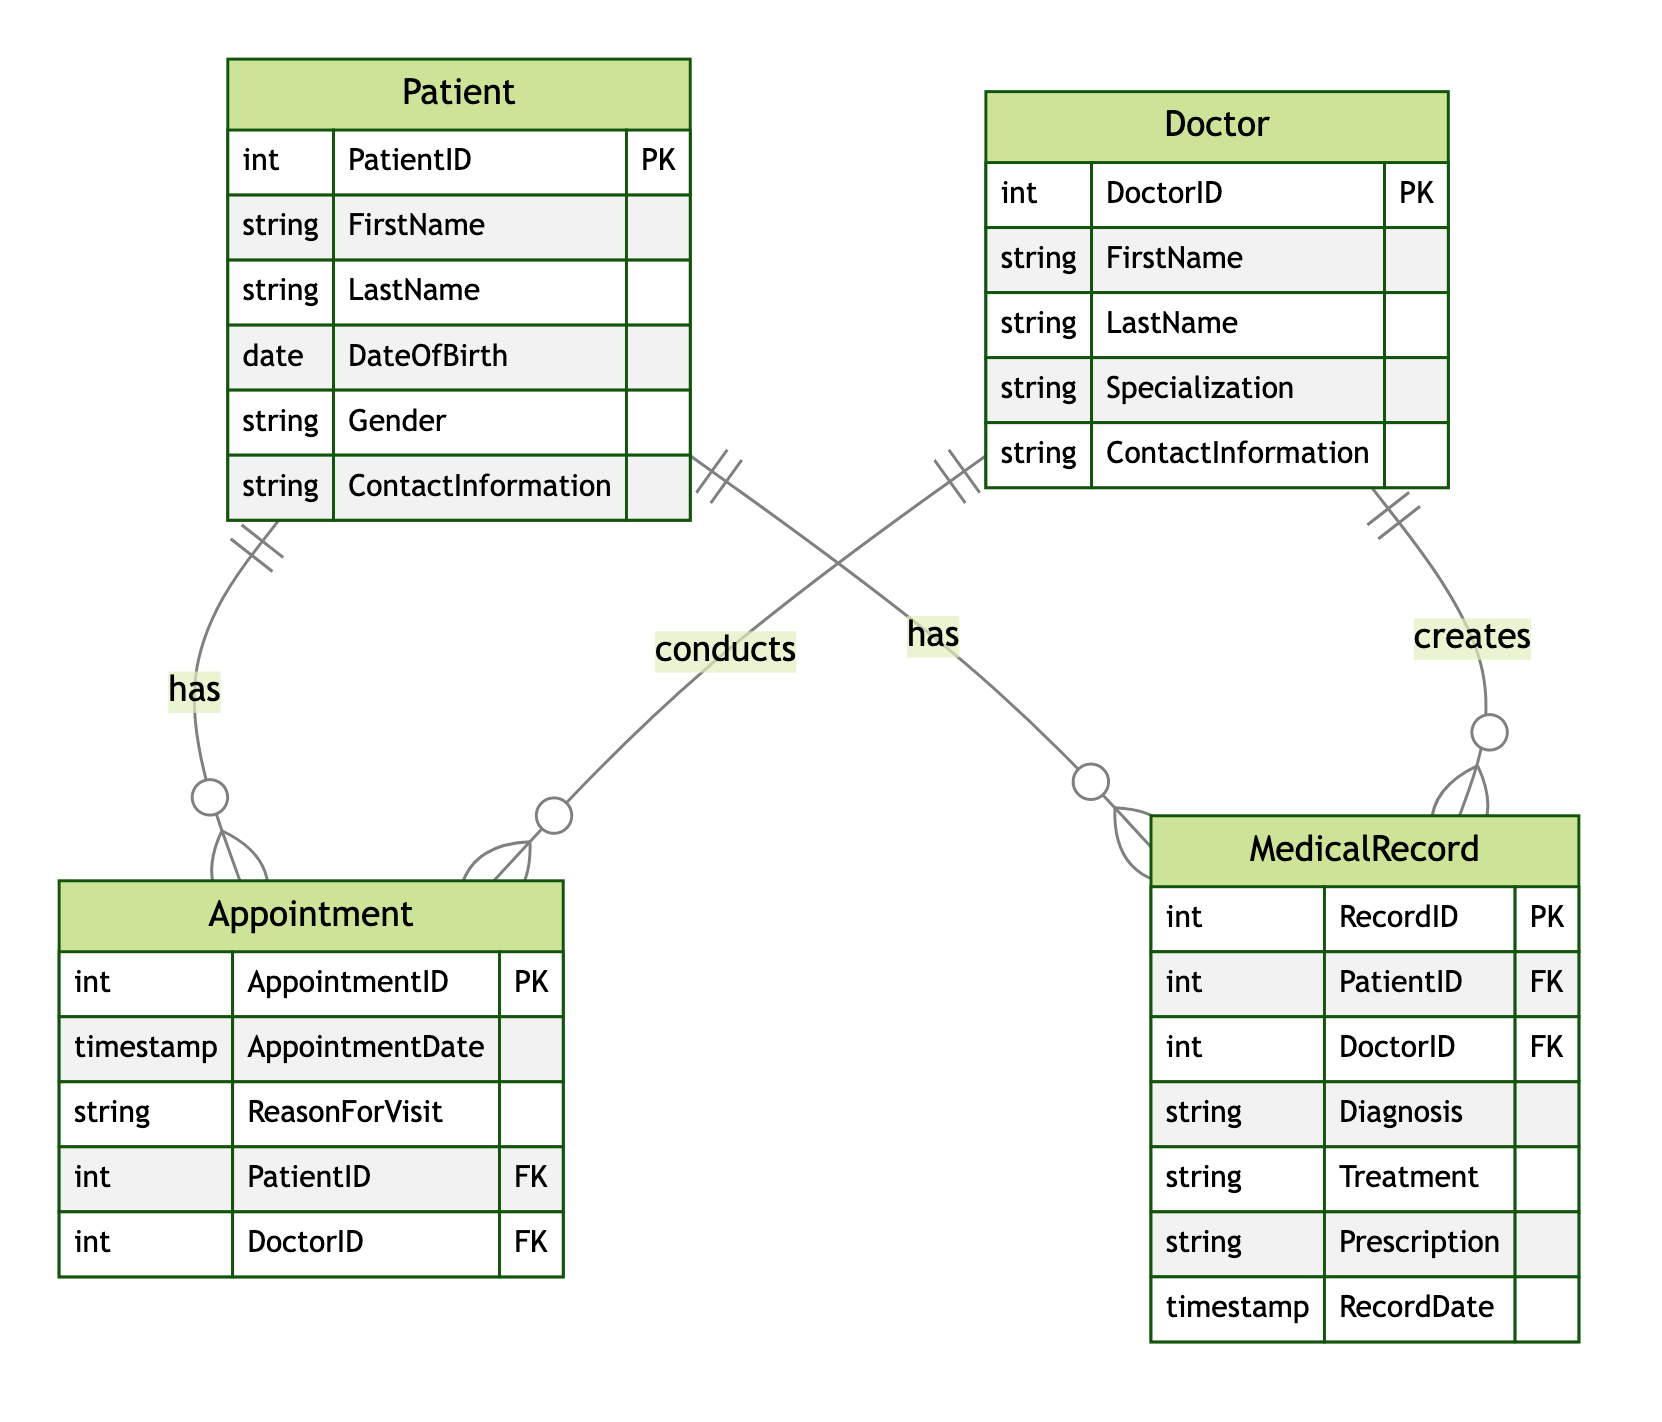What is the primary key for the Patient entity? The primary key is specified in the diagram as "PatientID," which uniquely identifies each patient in the database.
Answer: PatientID How many attributes are there in the Doctor entity? By counting the attributes listed under the Doctor entity, we find that there are five: DoctorID, FirstName, LastName, Specialization, and ContactInformation.
Answer: 5 Which entity is related to the Appointment entity as the one who conducts? The diagram indicates that the Doctor entity is related to the Appointment entity with the relationship labeled "conducts."
Answer: Doctor What is the relationship between MedicalRecord and Patient? The relationship depicted shows that the Patient "has" many MedicalRecords, establishing a direct association between the two entities.
Answer: has What is the foreign key in the Appointment entity? In the Appointment entity, the foreign keys are PatientID and DoctorID, which link the appointment to the corresponding patient and doctor.
Answer: PatientID, DoctorID How many entities are represented in the diagram? By enumerating the entities listed in the diagram, we count four: Patient, Doctor, Appointment, and MedicalRecord.
Answer: 4 What is the specialization attribute associated with which entity? The specialization attribute is associated with the Doctor entity, where it describes the field in which the doctor practices.
Answer: Doctor Which entity has the Diagnosis attribute? The Diagnosis attribute is included in the MedicalRecord entity, indicating that it contains information on diagnoses made by the doctor during patient visits.
Answer: MedicalRecord What type of relationship exists between Appointment and MedicalRecord? The diagram does not indicate any direct relationship between Appointment and MedicalRecord, meaning they are separate entities connected through Patient and Doctor entities.
Answer: None 